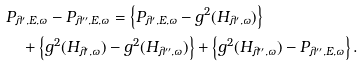<formula> <loc_0><loc_0><loc_500><loc_500>& P _ { \lambda ^ { \prime } , E , \omega } - P _ { \lambda ^ { \prime \prime } , E , \omega } = \left \{ P _ { \lambda ^ { \prime } , E , \omega } - g ^ { 2 } ( H _ { \lambda ^ { \prime } , \omega } ) \right \} \\ & \quad + \left \{ g ^ { 2 } ( H _ { \lambda ^ { \prime } , \omega } ) - g ^ { 2 } ( H _ { \lambda ^ { \prime \prime } , \omega } ) \right \} + \left \{ g ^ { 2 } ( H _ { \lambda ^ { \prime \prime } , \omega } ) - P _ { \lambda ^ { \prime \prime } , E , \omega } \right \} .</formula> 